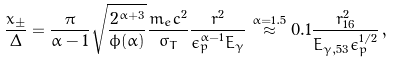<formula> <loc_0><loc_0><loc_500><loc_500>\frac { x _ { \pm } } { \Delta } = \frac { \pi } { \alpha - 1 } \sqrt { \frac { 2 ^ { \alpha + 3 } } { \phi ( \alpha ) } } \frac { m _ { e } c ^ { 2 } } { \sigma _ { T } } \frac { r ^ { 2 } } { \epsilon _ { p } ^ { \alpha - 1 } E _ { \gamma } } \stackrel { \alpha = 1 . 5 } { \approx } 0 . 1 \frac { r _ { 1 6 } ^ { 2 } } { E _ { \gamma , 5 3 } \epsilon _ { p } ^ { 1 / 2 } } \, ,</formula> 